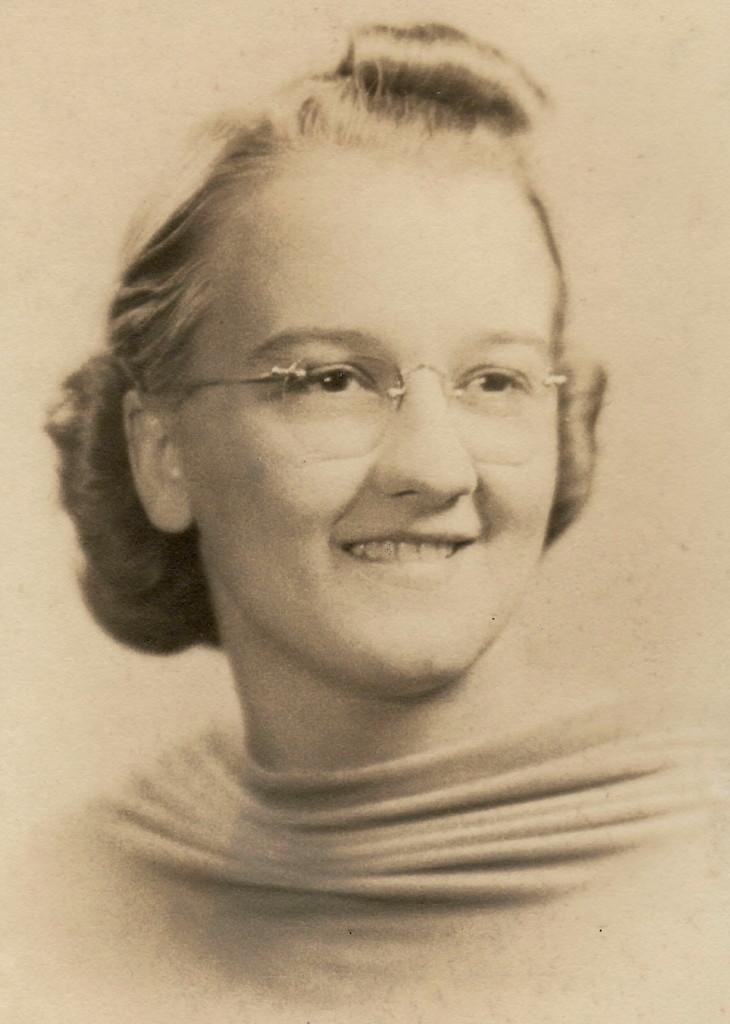What is the color scheme of the image? The image is black and white. Who is present in the image? There is a woman in the image. What accessory is the woman wearing? The woman is wearing spectacles. What type of calendar is hanging on the wall behind the woman in the image? There is no calendar visible in the image. How does the woman's stomach appear in the image? The image is black and white, and there is no specific focus on the woman's stomach. --- 